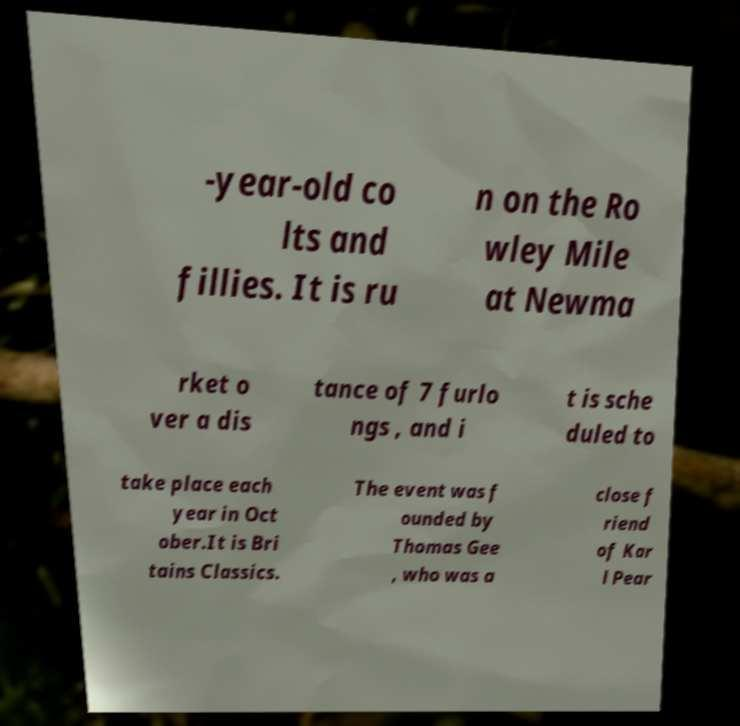Could you assist in decoding the text presented in this image and type it out clearly? -year-old co lts and fillies. It is ru n on the Ro wley Mile at Newma rket o ver a dis tance of 7 furlo ngs , and i t is sche duled to take place each year in Oct ober.It is Bri tains Classics. The event was f ounded by Thomas Gee , who was a close f riend of Kar l Pear 